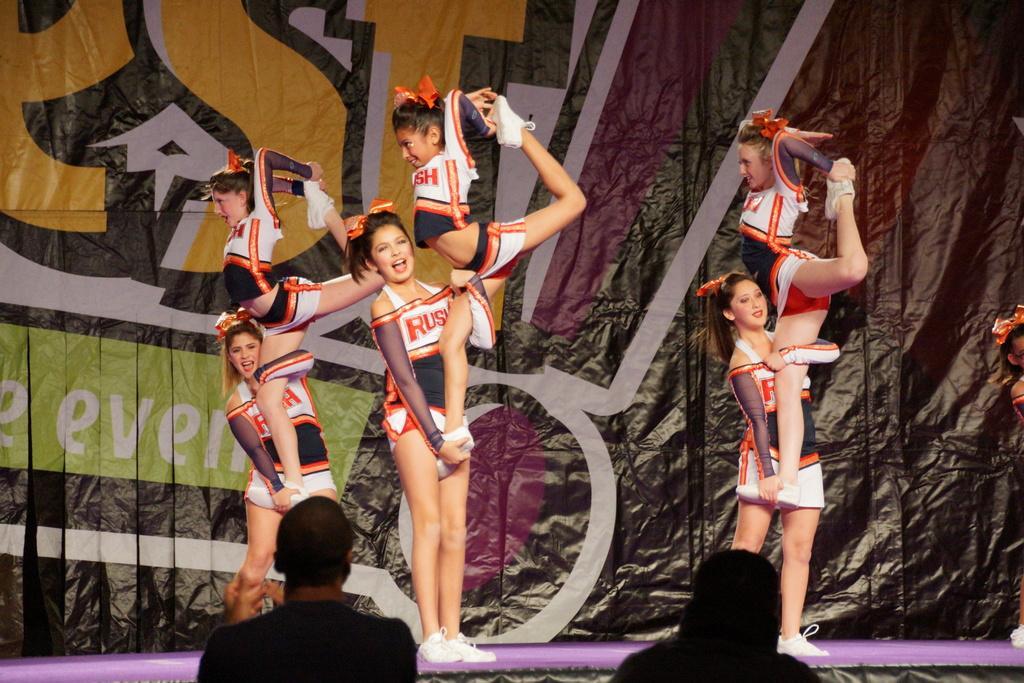Can you describe this image briefly? In this picture few girls performing gymnastics and I can see couple of them watching and I can see a banner with some text in the back. 